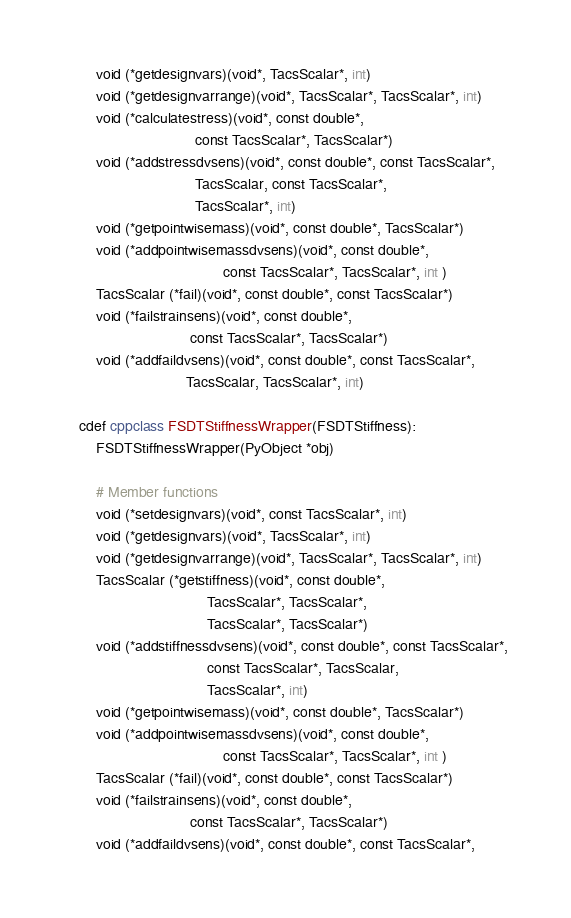<code> <loc_0><loc_0><loc_500><loc_500><_Cython_>        void (*getdesignvars)(void*, TacsScalar*, int)
        void (*getdesignvarrange)(void*, TacsScalar*, TacsScalar*, int)
        void (*calculatestress)(void*, const double*,
                                const TacsScalar*, TacsScalar*)
        void (*addstressdvsens)(void*, const double*, const TacsScalar*,
                                TacsScalar, const TacsScalar*,
                                TacsScalar*, int)
        void (*getpointwisemass)(void*, const double*, TacsScalar*)
        void (*addpointwisemassdvsens)(void*, const double*,
                                       const TacsScalar*, TacsScalar*, int )
        TacsScalar (*fail)(void*, const double*, const TacsScalar*)
        void (*failstrainsens)(void*, const double*,
                               const TacsScalar*, TacsScalar*)
        void (*addfaildvsens)(void*, const double*, const TacsScalar*,
                              TacsScalar, TacsScalar*, int)

    cdef cppclass FSDTStiffnessWrapper(FSDTStiffness):
        FSDTStiffnessWrapper(PyObject *obj)

        # Member functions
        void (*setdesignvars)(void*, const TacsScalar*, int)
        void (*getdesignvars)(void*, TacsScalar*, int)
        void (*getdesignvarrange)(void*, TacsScalar*, TacsScalar*, int)
        TacsScalar (*getstiffness)(void*, const double*,
                                   TacsScalar*, TacsScalar*,
                                   TacsScalar*, TacsScalar*)
        void (*addstiffnessdvsens)(void*, const double*, const TacsScalar*,
                                   const TacsScalar*, TacsScalar,
                                   TacsScalar*, int)
        void (*getpointwisemass)(void*, const double*, TacsScalar*)
        void (*addpointwisemassdvsens)(void*, const double*,
                                       const TacsScalar*, TacsScalar*, int )
        TacsScalar (*fail)(void*, const double*, const TacsScalar*)
        void (*failstrainsens)(void*, const double*,
                               const TacsScalar*, TacsScalar*)
        void (*addfaildvsens)(void*, const double*, const TacsScalar*,</code> 